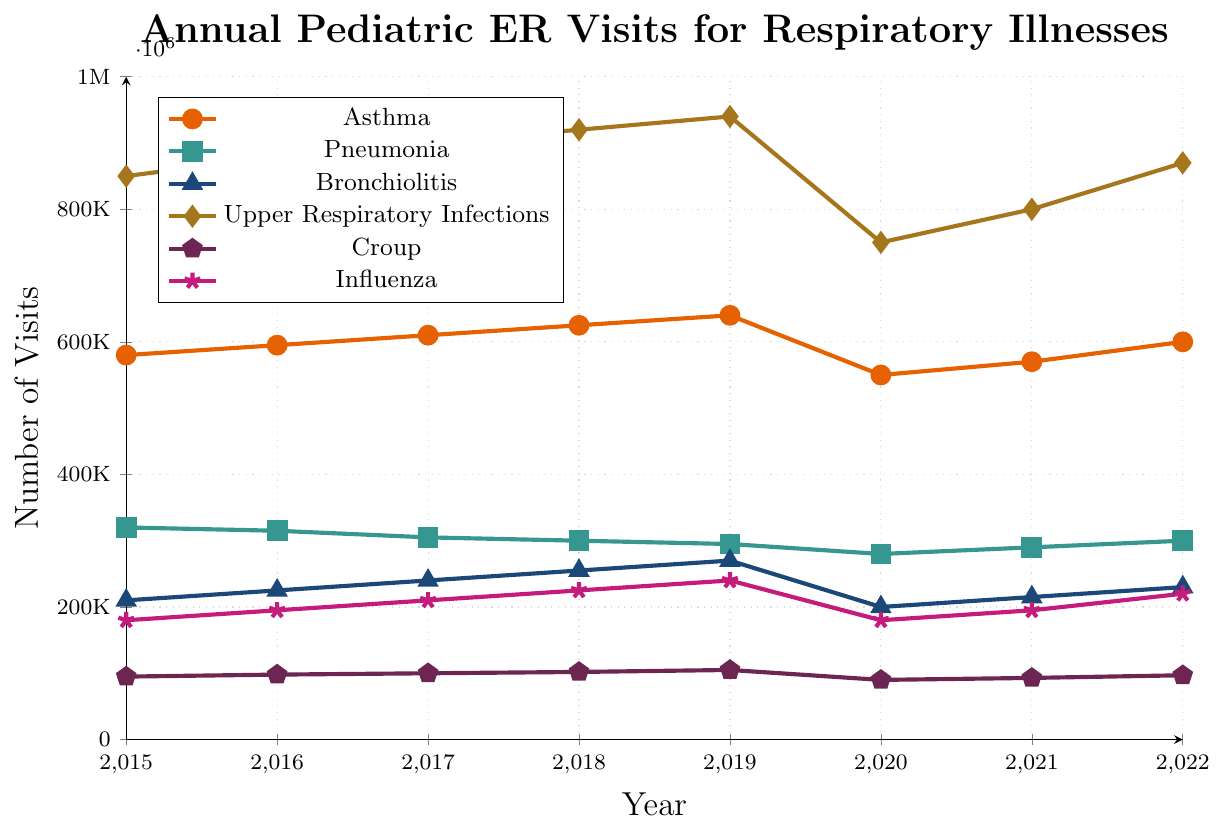Which year had the highest number of pediatric ER visits due to Upper Respiratory Infections? To find the year with the highest number of visits for Upper Respiratory Infections, we look at the data points for each year and find the maximum value. The highest number is 940,000 in 2019.
Answer: 2019 Compare the total annual pediatric ER visits for Asthma in 2015 and 2020. We need to look at the data for Asthma in 2015 and 2020. In 2015, there were 580,000 visits, and in 2020, there were 550,000 visits. Comparing these, 2020 had 30,000 fewer visits than 2015.
Answer: Asthma visits decreased by 30,000 from 2015 to 2020 Which condition showed a consistent increase in pediatric ER visits from 2015 to 2019? We analyze the trend for each condition from 2015 to 2019. Asthma, Bronchiolitis, Upper Respiratory Infections, and Croup all show an increasing trend.
Answer: Asthma, Bronchiolitis, Upper Respiratory Infections, and Croup How did pediatric ER visits for Pneumonia change between 2015 and 2022? For Pneumonia, compare the 2015 value (320,000) and 2022 value (300,000). There is a decrease of 20,000 visits over this period.
Answer: Decreased by 20,000 What was the average number of pediatric ER visits for Influenza from 2015 to 2022? Sum the annual visits for Influenza from 2015 to 2022, then divide by the number of years (8). The sum is 180,000 + 195,000 + 210,000 + 225,000 + 240,000 + 180,000 + 195,000 + 220,000 = 1,645,000. The average = 1,645,000 / 8 = 205,625.
Answer: 205,625 Identify the year with the lowest number of pediatric ER visits for Bronchiolitis. Look at the data points for Bronchiolitis over the years. The lowest value is 200,000 in 2020.
Answer: 2020 How did the number of pediatric ER visits for Croup in 2020 compare to the number in 2022? For Croup, the visits were 90,000 in 2020 and 97,000 in 2022. Comparing these, there is an increase of 7,000 visits from 2020 to 2022.
Answer: Increased by 7,000 Calculate the difference in pediatric ER visits for Upper Respiratory Infections between 2019 and 2020. The visits for Upper Respiratory Infections were 940,000 in 2019 and 750,000 in 2020. The difference between these values is 940,000 - 750,000 = 190,000.
Answer: Decreased by 190,000 